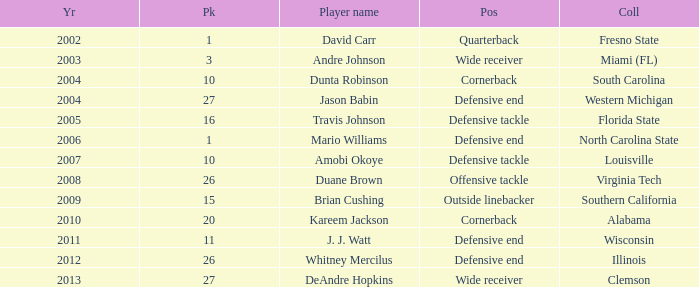Parse the full table. {'header': ['Yr', 'Pk', 'Player name', 'Pos', 'Coll'], 'rows': [['2002', '1', 'David Carr', 'Quarterback', 'Fresno State'], ['2003', '3', 'Andre Johnson', 'Wide receiver', 'Miami (FL)'], ['2004', '10', 'Dunta Robinson', 'Cornerback', 'South Carolina'], ['2004', '27', 'Jason Babin', 'Defensive end', 'Western Michigan'], ['2005', '16', 'Travis Johnson', 'Defensive tackle', 'Florida State'], ['2006', '1', 'Mario Williams', 'Defensive end', 'North Carolina State'], ['2007', '10', 'Amobi Okoye', 'Defensive tackle', 'Louisville'], ['2008', '26', 'Duane Brown', 'Offensive tackle', 'Virginia Tech'], ['2009', '15', 'Brian Cushing', 'Outside linebacker', 'Southern California'], ['2010', '20', 'Kareem Jackson', 'Cornerback', 'Alabama'], ['2011', '11', 'J. J. Watt', 'Defensive end', 'Wisconsin'], ['2012', '26', 'Whitney Mercilus', 'Defensive end', 'Illinois'], ['2013', '27', 'DeAndre Hopkins', 'Wide receiver', 'Clemson']]} What pick was mario williams before 2006? None. 